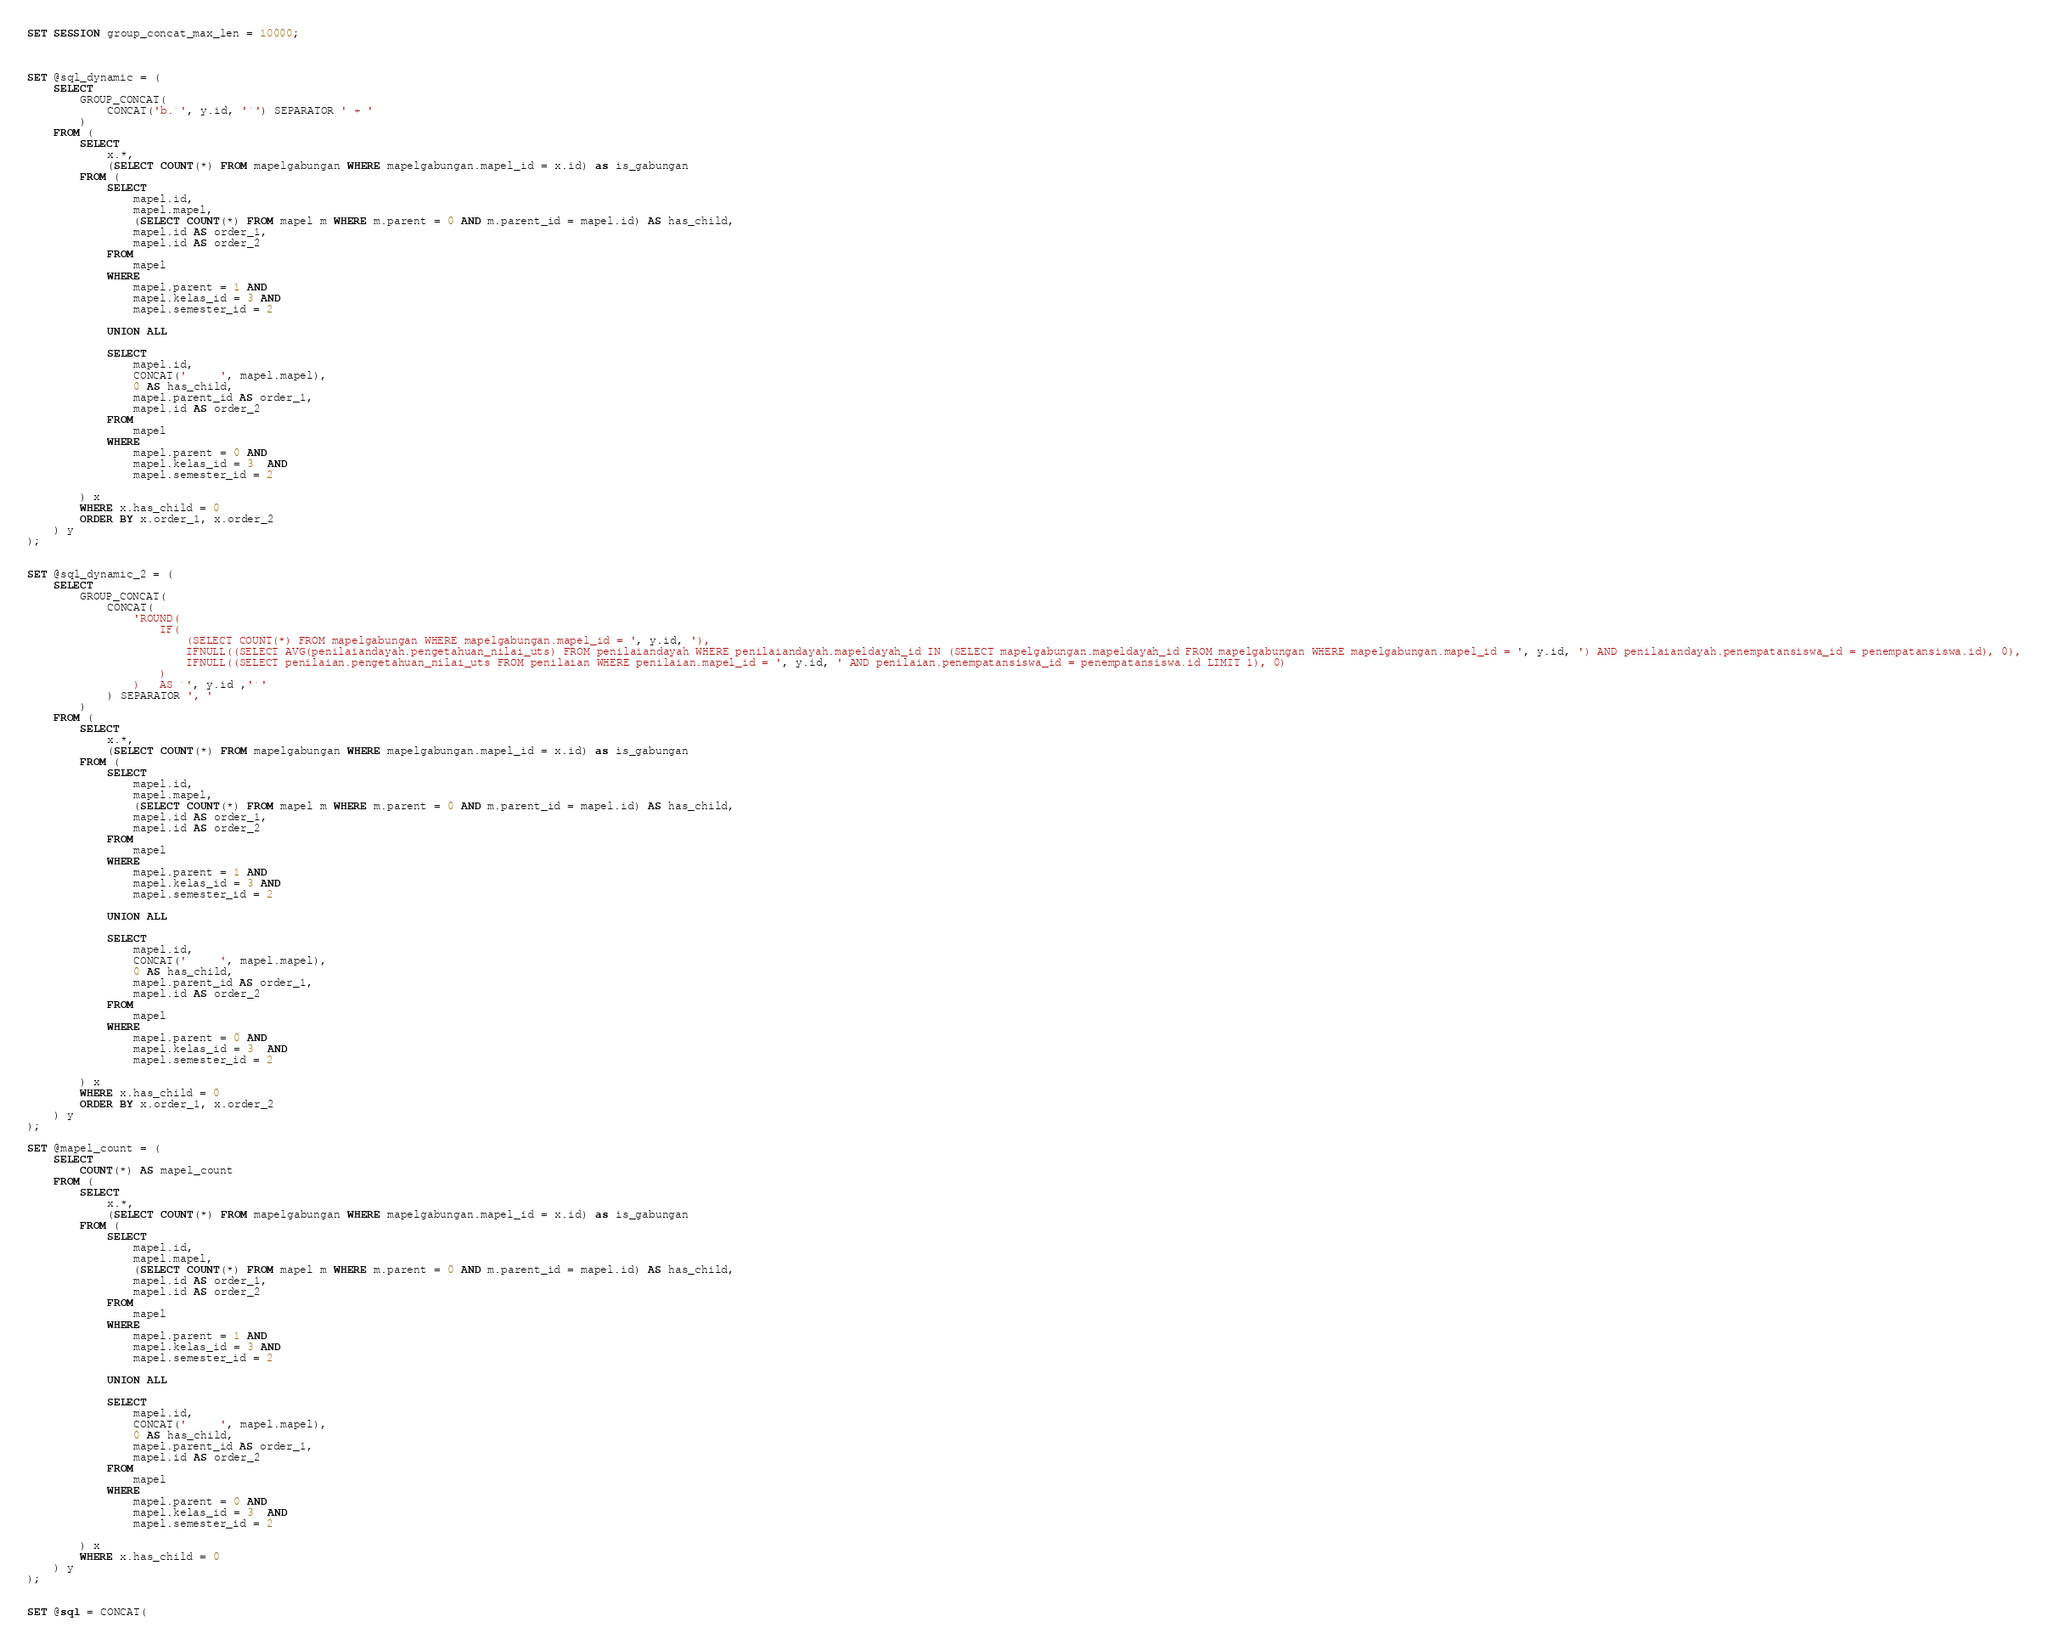<code> <loc_0><loc_0><loc_500><loc_500><_SQL_>SET SESSION group_concat_max_len = 10000;



SET @sql_dynamic = (
	SELECT 
		GROUP_CONCAT(
			CONCAT('b.`', y.id, '`') SEPARATOR ' + '
		) 
	FROM (
		SELECT 
			x.*,
			(SELECT COUNT(*) FROM mapelgabungan WHERE mapelgabungan.mapel_id = x.id) as is_gabungan
		FROM (
			SELECT
				mapel.id,
				mapel.mapel,
				(SELECT COUNT(*) FROM mapel m WHERE m.parent = 0 AND m.parent_id = mapel.id) AS has_child,
				mapel.id AS order_1,
				mapel.id AS order_2
			FROM
				mapel
			WHERE 
				mapel.parent = 1 AND 
				mapel.kelas_id = 3 AND 
				mapel.semester_id = 2

			UNION ALL

			SELECT
				mapel.id,
				CONCAT('     ', mapel.mapel),
				0 AS has_child,
				mapel.parent_id AS order_1,
				mapel.id AS order_2
			FROM
				mapel
			WHERE 
				mapel.parent = 0 AND 
				mapel.kelas_id = 3  AND 
				mapel.semester_id = 2

		) x 
		WHERE x.has_child = 0
		ORDER BY x.order_1, x.order_2
	) y 
);


SET @sql_dynamic_2 = (
	SELECT 
		GROUP_CONCAT(
			CONCAT(
				'ROUND(
					IF(
						(SELECT COUNT(*) FROM mapelgabungan WHERE mapelgabungan.mapel_id = ', y.id, '), 
						IFNULL((SELECT AVG(penilaiandayah.pengetahuan_nilai_uts) FROM penilaiandayah WHERE penilaiandayah.mapeldayah_id IN (SELECT mapelgabungan.mapeldayah_id FROM mapelgabungan WHERE mapelgabungan.mapel_id = ', y.id, ') AND penilaiandayah.penempatansiswa_id = penempatansiswa.id), 0),
						IFNULL((SELECT penilaian.pengetahuan_nilai_uts FROM penilaian WHERE penilaian.mapel_id = ', y.id, ' AND penilaian.penempatansiswa_id = penempatansiswa.id LIMIT 1), 0)
					)
				)	AS `', y.id ,'`'
			) SEPARATOR ', '
		) 
	FROM (
		SELECT 
			x.*,
			(SELECT COUNT(*) FROM mapelgabungan WHERE mapelgabungan.mapel_id = x.id) as is_gabungan
		FROM (
			SELECT
				mapel.id,
				mapel.mapel,
				(SELECT COUNT(*) FROM mapel m WHERE m.parent = 0 AND m.parent_id = mapel.id) AS has_child,
				mapel.id AS order_1,
				mapel.id AS order_2
			FROM
				mapel
			WHERE 
				mapel.parent = 1 AND 
				mapel.kelas_id = 3 AND 
				mapel.semester_id = 2

			UNION ALL

			SELECT
				mapel.id,
				CONCAT('     ', mapel.mapel),
				0 AS has_child,
				mapel.parent_id AS order_1,
				mapel.id AS order_2
			FROM
				mapel
			WHERE 
				mapel.parent = 0 AND 
				mapel.kelas_id = 3  AND 
				mapel.semester_id = 2

		) x 
		WHERE x.has_child = 0
		ORDER BY x.order_1, x.order_2
	) y 
);

SET @mapel_count = (
	SELECT 
		COUNT(*) AS mapel_count
	FROM (
		SELECT 
			x.*,
			(SELECT COUNT(*) FROM mapelgabungan WHERE mapelgabungan.mapel_id = x.id) as is_gabungan
		FROM (
			SELECT
				mapel.id,
				mapel.mapel,
				(SELECT COUNT(*) FROM mapel m WHERE m.parent = 0 AND m.parent_id = mapel.id) AS has_child,
				mapel.id AS order_1,
				mapel.id AS order_2
			FROM
				mapel
			WHERE 
				mapel.parent = 1 AND 
				mapel.kelas_id = 3 AND 
				mapel.semester_id = 2

			UNION ALL

			SELECT
				mapel.id,
				CONCAT('     ', mapel.mapel),
				0 AS has_child,
				mapel.parent_id AS order_1,
				mapel.id AS order_2
			FROM
				mapel
			WHERE 
				mapel.parent = 0 AND 
				mapel.kelas_id = 3  AND 
				mapel.semester_id = 2

		) x 
		WHERE x.has_child = 0
	) y
);


SET @sql = CONCAT(</code> 